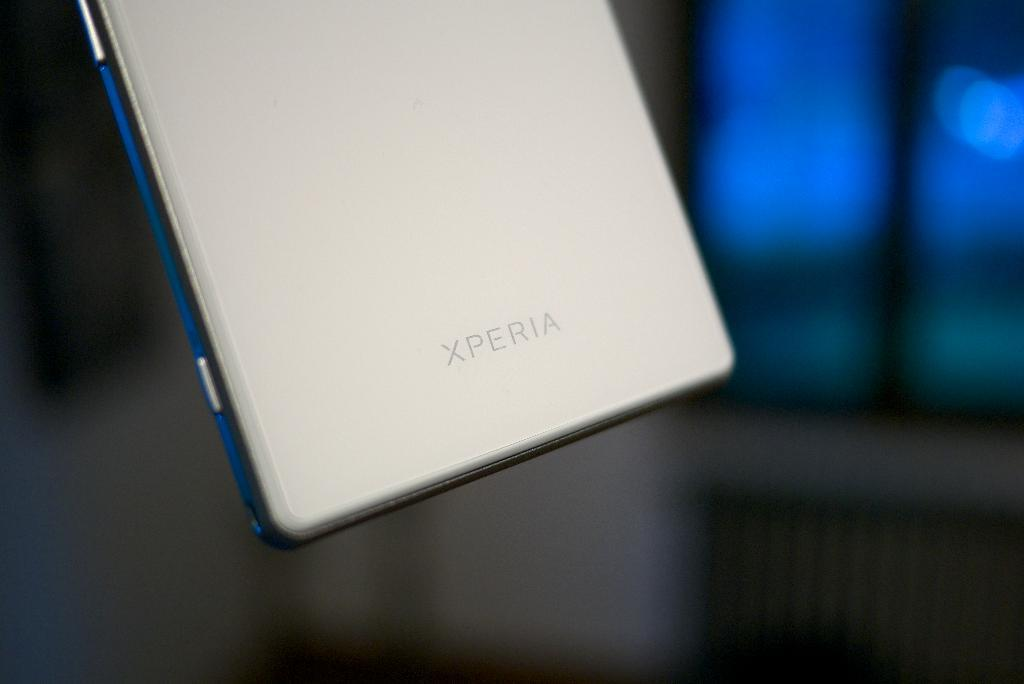Provide a one-sentence caption for the provided image. the back of a silver xperia phone being held in midair. 